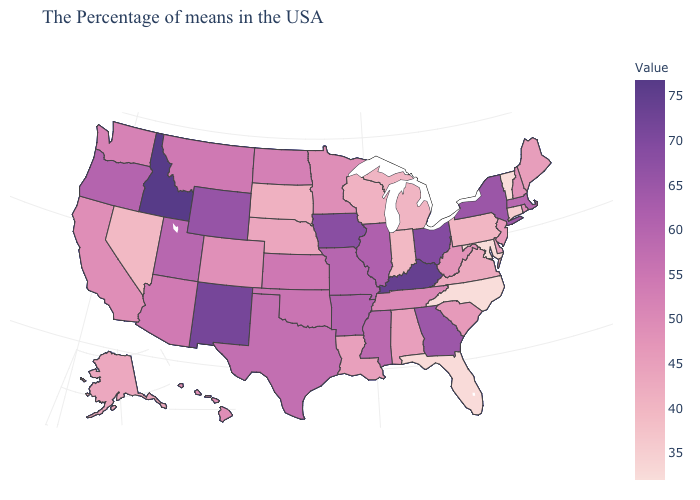Does South Carolina have a lower value than Oregon?
Keep it brief. Yes. Is the legend a continuous bar?
Write a very short answer. Yes. Among the states that border Idaho , which have the lowest value?
Be succinct. Nevada. Does Wisconsin have a higher value than North Carolina?
Short answer required. Yes. Is the legend a continuous bar?
Keep it brief. Yes. Does Alabama have a lower value than North Dakota?
Be succinct. Yes. Is the legend a continuous bar?
Concise answer only. Yes. 